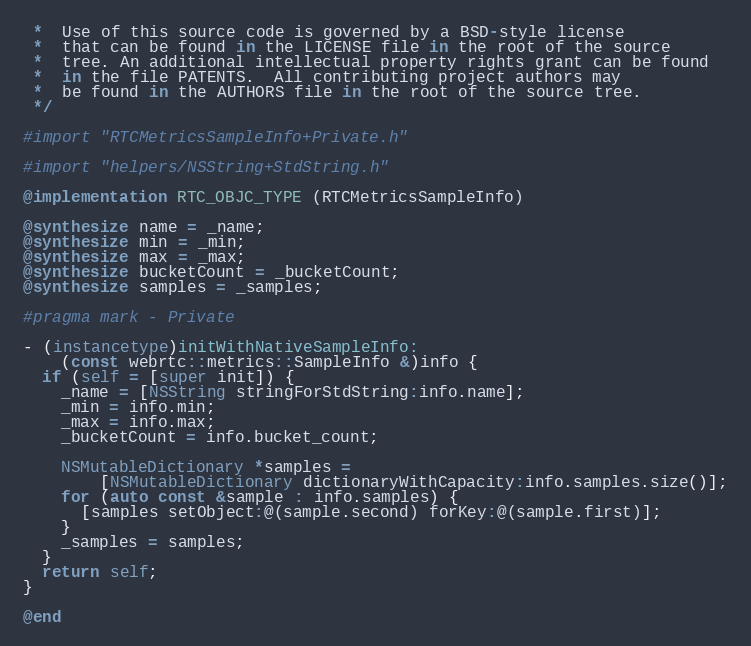Convert code to text. <code><loc_0><loc_0><loc_500><loc_500><_ObjectiveC_> *  Use of this source code is governed by a BSD-style license
 *  that can be found in the LICENSE file in the root of the source
 *  tree. An additional intellectual property rights grant can be found
 *  in the file PATENTS.  All contributing project authors may
 *  be found in the AUTHORS file in the root of the source tree.
 */

#import "RTCMetricsSampleInfo+Private.h"

#import "helpers/NSString+StdString.h"

@implementation RTC_OBJC_TYPE (RTCMetricsSampleInfo)

@synthesize name = _name;
@synthesize min = _min;
@synthesize max = _max;
@synthesize bucketCount = _bucketCount;
@synthesize samples = _samples;

#pragma mark - Private

- (instancetype)initWithNativeSampleInfo:
    (const webrtc::metrics::SampleInfo &)info {
  if (self = [super init]) {
    _name = [NSString stringForStdString:info.name];
    _min = info.min;
    _max = info.max;
    _bucketCount = info.bucket_count;

    NSMutableDictionary *samples =
        [NSMutableDictionary dictionaryWithCapacity:info.samples.size()];
    for (auto const &sample : info.samples) {
      [samples setObject:@(sample.second) forKey:@(sample.first)];
    }
    _samples = samples;
  }
  return self;
}

@end
</code> 